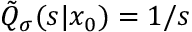Convert formula to latex. <formula><loc_0><loc_0><loc_500><loc_500>\tilde { Q } _ { \sigma } ( s | x _ { 0 } ) = 1 / s</formula> 